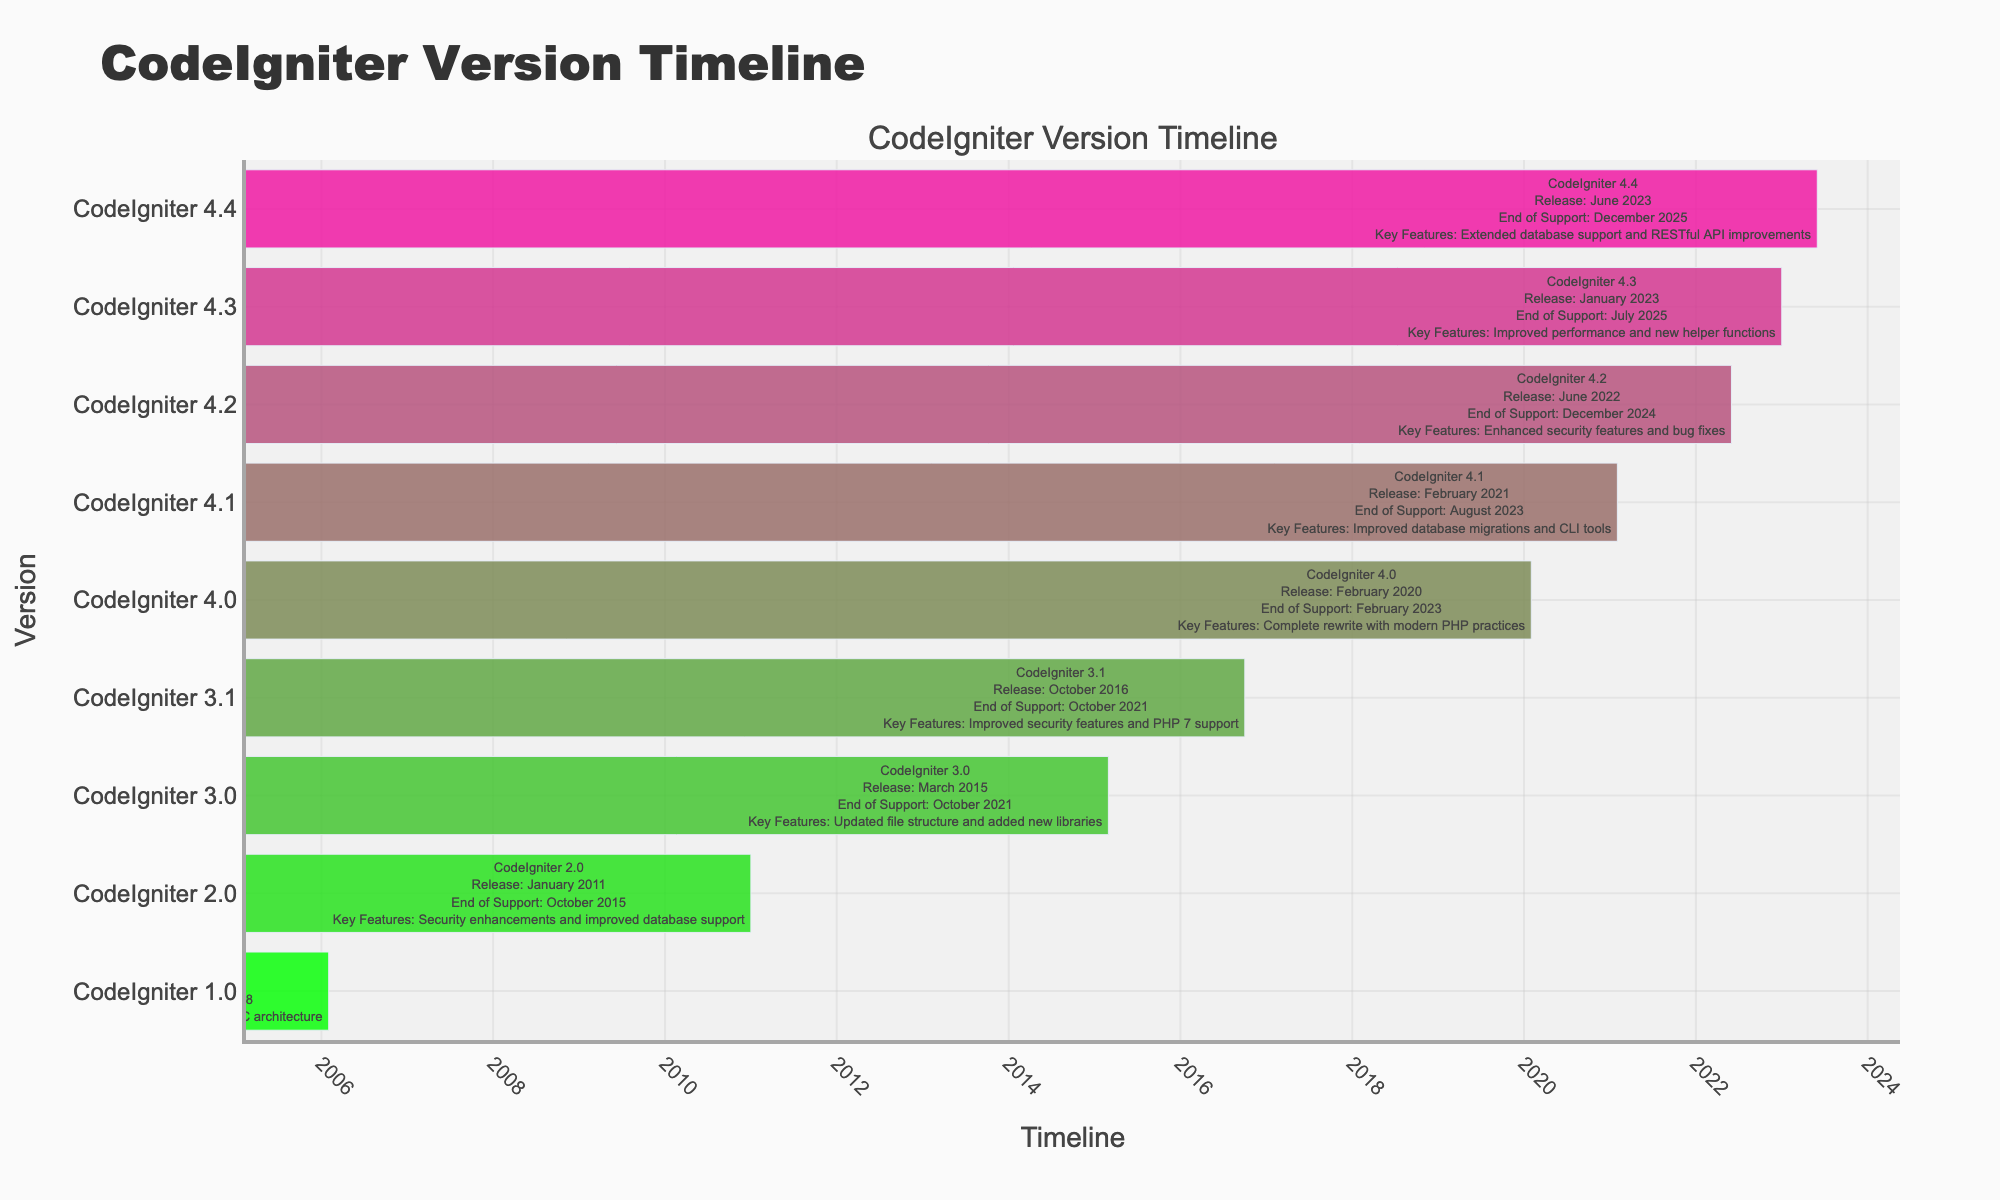What is the release date of CodeIgniter 4.0? According to the table, CodeIgniter 4.0 was released in February 2020.
Answer: February 2020 When does support end for CodeIgniter 3.1? By looking at the table, it shows that the end of support for CodeIgniter 3.1 is October 2021.
Answer: October 2021 Which version has improved database migrations and CLI tools? The table indicates that CodeIgniter 4.1 has improved database migrations and CLI tools as part of its key features.
Answer: CodeIgniter 4.1 Is there a version with an end of support date in 2023? Yes, CodeIgniter 4.1 has its end of support date in August 2023.
Answer: Yes What is the difference in support end dates between CodeIgniter 3.0 and CodeIgniter 4.2? CodeIgniter 3.0 ends support in October 2021 and CodeIgniter 4.2 ends support in December 2024. The difference is about 3 years and 2 months.
Answer: 3 years and 2 months What is the key feature of CodeIgniter 4.3, and how does it compare to the previous version, 4.2? CodeIgniter 4.3 has improved performance and new helper functions. Compared to 4.2, which focused on enhanced security features and bug fixes, 4.3 shifts the focus to performance improvements.
Answer: Improved performance and new helper functions; focuses on performance over security enhancements How many versions of CodeIgniter were released before 2015? The versions released before 2015 are CodeIgniter 1.0, CodeIgniter 2.0, and CodeIgniter 3.0. This means there are 3 versions released before 2015.
Answer: 3 Which version introduced a complete rewrite and what is its end of support date? CodeIgniter 4.0 introduced a complete rewrite with modern PHP practices and its end of support date is February 2023.
Answer: February 2023 What is the average support length for CodeIgniter versions released after 2015? The versions released after 2015 are CodeIgniter 3.0, CodeIgniter 3.1, CodeIgniter 4.0, CodeIgniter 4.1, CodeIgniter 4.2, CodeIgniter 4.3, and CodeIgniter 4.4. The support lengths are from 6 years to 2 years. Summing the support lengths and dividing by 7 gives an average support length of around 3.43 years.
Answer: Approximately 3.43 years 